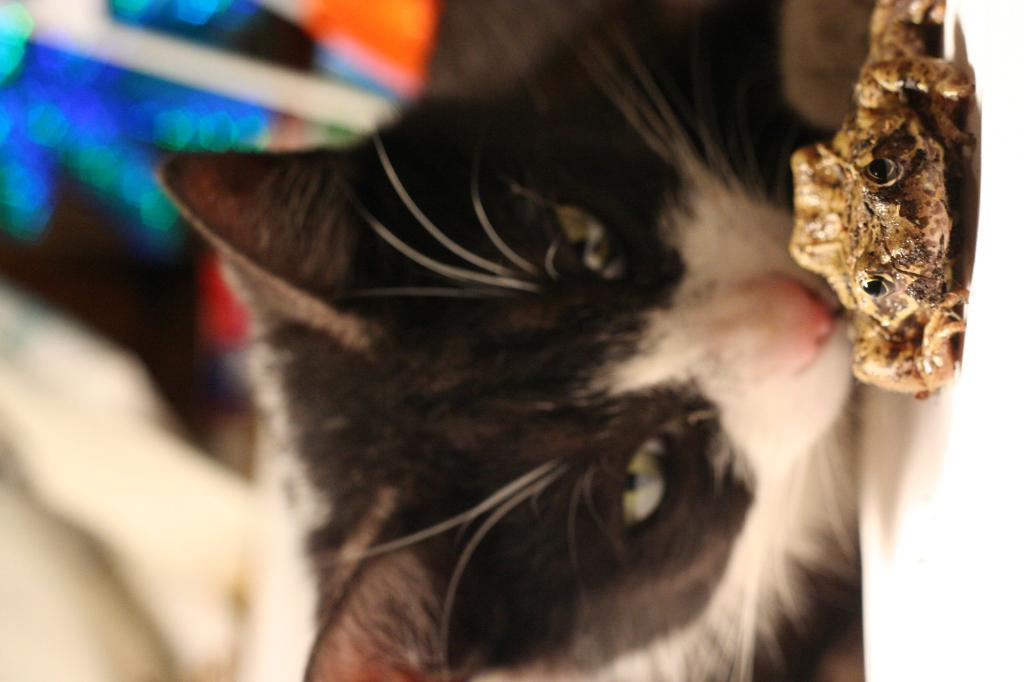What type of animal can be seen in the image? There is a cat in the image. Can you describe the appearance of the cat? The cat is black and white in color. What other animal is present in the image? There is a frog in the image. How would you describe the appearance of the frog? The frog is brown in color. What can be observed about the background of the image? The background of the image is blurred. What type of sack can be seen in the image? There is no sack present in the image. Can you tell me how many dogs are in the image? There is no dog present in the image. 